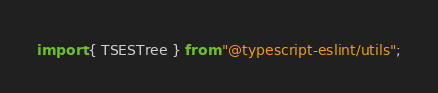<code> <loc_0><loc_0><loc_500><loc_500><_TypeScript_>import { TSESTree } from "@typescript-eslint/utils";</code> 